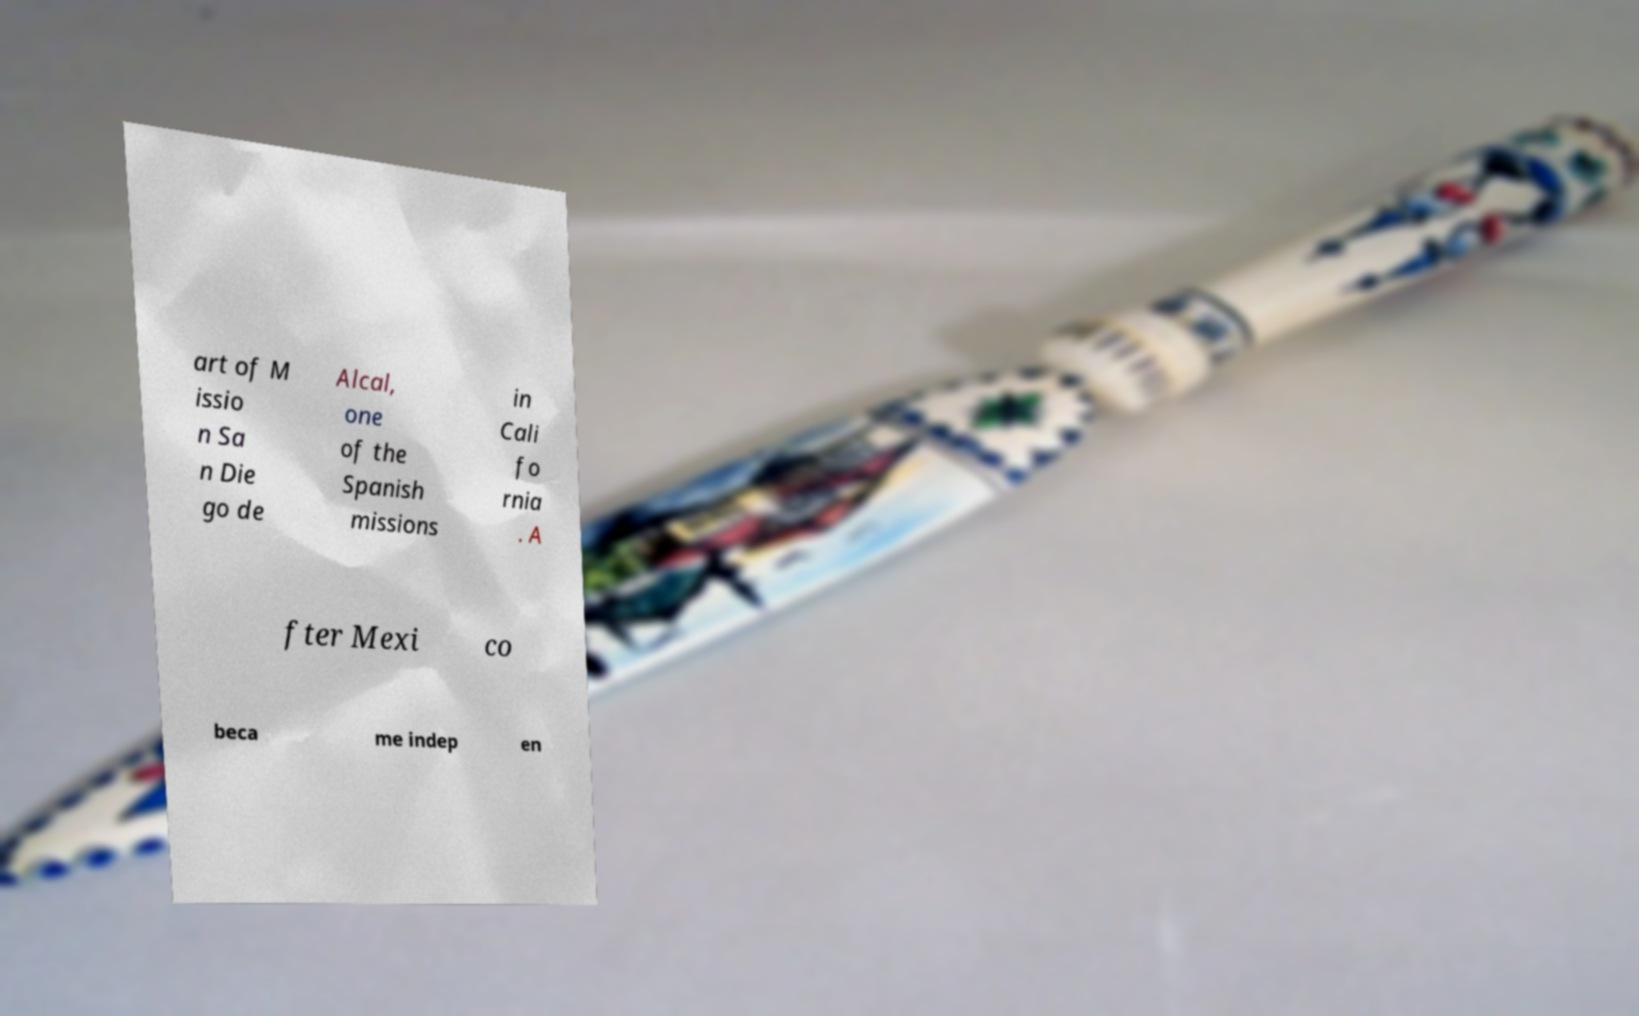What messages or text are displayed in this image? I need them in a readable, typed format. art of M issio n Sa n Die go de Alcal, one of the Spanish missions in Cali fo rnia . A fter Mexi co beca me indep en 